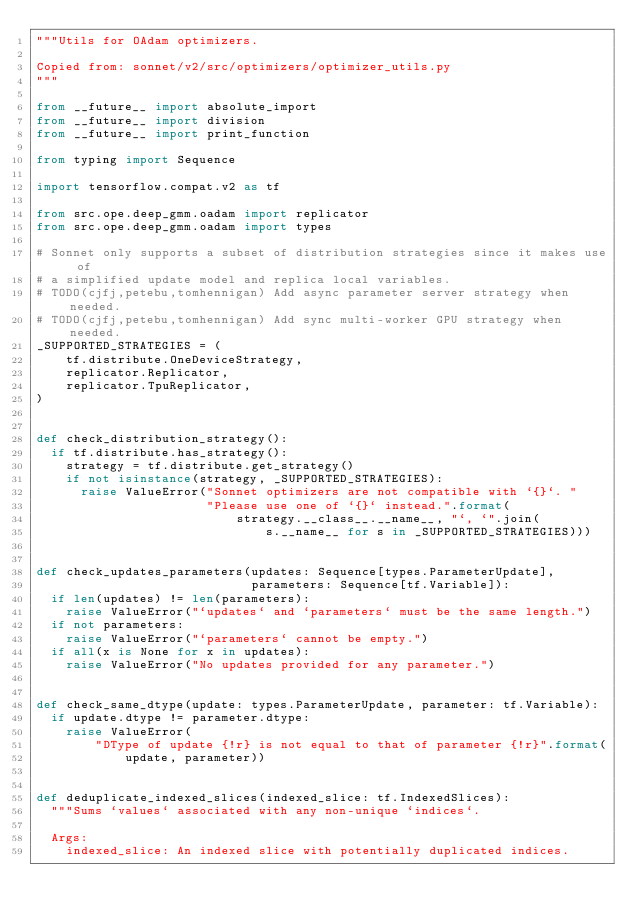<code> <loc_0><loc_0><loc_500><loc_500><_Python_>"""Utils for OAdam optimizers.

Copied from: sonnet/v2/src/optimizers/optimizer_utils.py
"""

from __future__ import absolute_import
from __future__ import division
from __future__ import print_function

from typing import Sequence

import tensorflow.compat.v2 as tf

from src.ope.deep_gmm.oadam import replicator
from src.ope.deep_gmm.oadam import types

# Sonnet only supports a subset of distribution strategies since it makes use of
# a simplified update model and replica local variables.
# TODO(cjfj,petebu,tomhennigan) Add async parameter server strategy when needed.
# TODO(cjfj,petebu,tomhennigan) Add sync multi-worker GPU strategy when needed.
_SUPPORTED_STRATEGIES = (
    tf.distribute.OneDeviceStrategy,
    replicator.Replicator,
    replicator.TpuReplicator,
)


def check_distribution_strategy():
  if tf.distribute.has_strategy():
    strategy = tf.distribute.get_strategy()
    if not isinstance(strategy, _SUPPORTED_STRATEGIES):
      raise ValueError("Sonnet optimizers are not compatible with `{}`. "
                       "Please use one of `{}` instead.".format(
                           strategy.__class__.__name__, "`, `".join(
                               s.__name__ for s in _SUPPORTED_STRATEGIES)))


def check_updates_parameters(updates: Sequence[types.ParameterUpdate],
                             parameters: Sequence[tf.Variable]):
  if len(updates) != len(parameters):
    raise ValueError("`updates` and `parameters` must be the same length.")
  if not parameters:
    raise ValueError("`parameters` cannot be empty.")
  if all(x is None for x in updates):
    raise ValueError("No updates provided for any parameter.")


def check_same_dtype(update: types.ParameterUpdate, parameter: tf.Variable):
  if update.dtype != parameter.dtype:
    raise ValueError(
        "DType of update {!r} is not equal to that of parameter {!r}".format(
            update, parameter))


def deduplicate_indexed_slices(indexed_slice: tf.IndexedSlices):
  """Sums `values` associated with any non-unique `indices`.

  Args:
    indexed_slice: An indexed slice with potentially duplicated indices.
</code> 